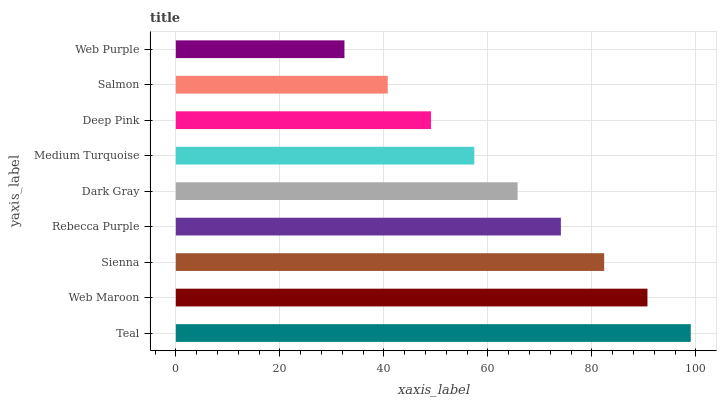Is Web Purple the minimum?
Answer yes or no. Yes. Is Teal the maximum?
Answer yes or no. Yes. Is Web Maroon the minimum?
Answer yes or no. No. Is Web Maroon the maximum?
Answer yes or no. No. Is Teal greater than Web Maroon?
Answer yes or no. Yes. Is Web Maroon less than Teal?
Answer yes or no. Yes. Is Web Maroon greater than Teal?
Answer yes or no. No. Is Teal less than Web Maroon?
Answer yes or no. No. Is Dark Gray the high median?
Answer yes or no. Yes. Is Dark Gray the low median?
Answer yes or no. Yes. Is Rebecca Purple the high median?
Answer yes or no. No. Is Sienna the low median?
Answer yes or no. No. 